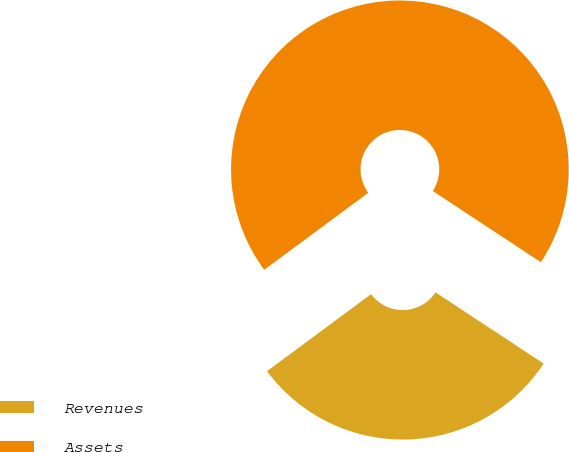Convert chart. <chart><loc_0><loc_0><loc_500><loc_500><pie_chart><fcel>Revenues<fcel>Assets<nl><fcel>30.58%<fcel>69.42%<nl></chart> 